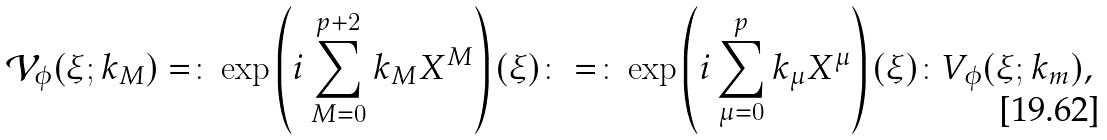<formula> <loc_0><loc_0><loc_500><loc_500>\mathcal { V } _ { \phi } ( \xi ; k _ { M } ) = \colon \exp \left ( i \sum _ { M = 0 } ^ { p + 2 } k _ { M } X ^ { M } \right ) ( \xi ) \colon = \colon \exp \left ( i \sum _ { \mu = 0 } ^ { p } k _ { \mu } X ^ { \mu } \right ) ( \xi ) \colon V _ { \phi } ( \xi ; k _ { m } ) ,</formula> 